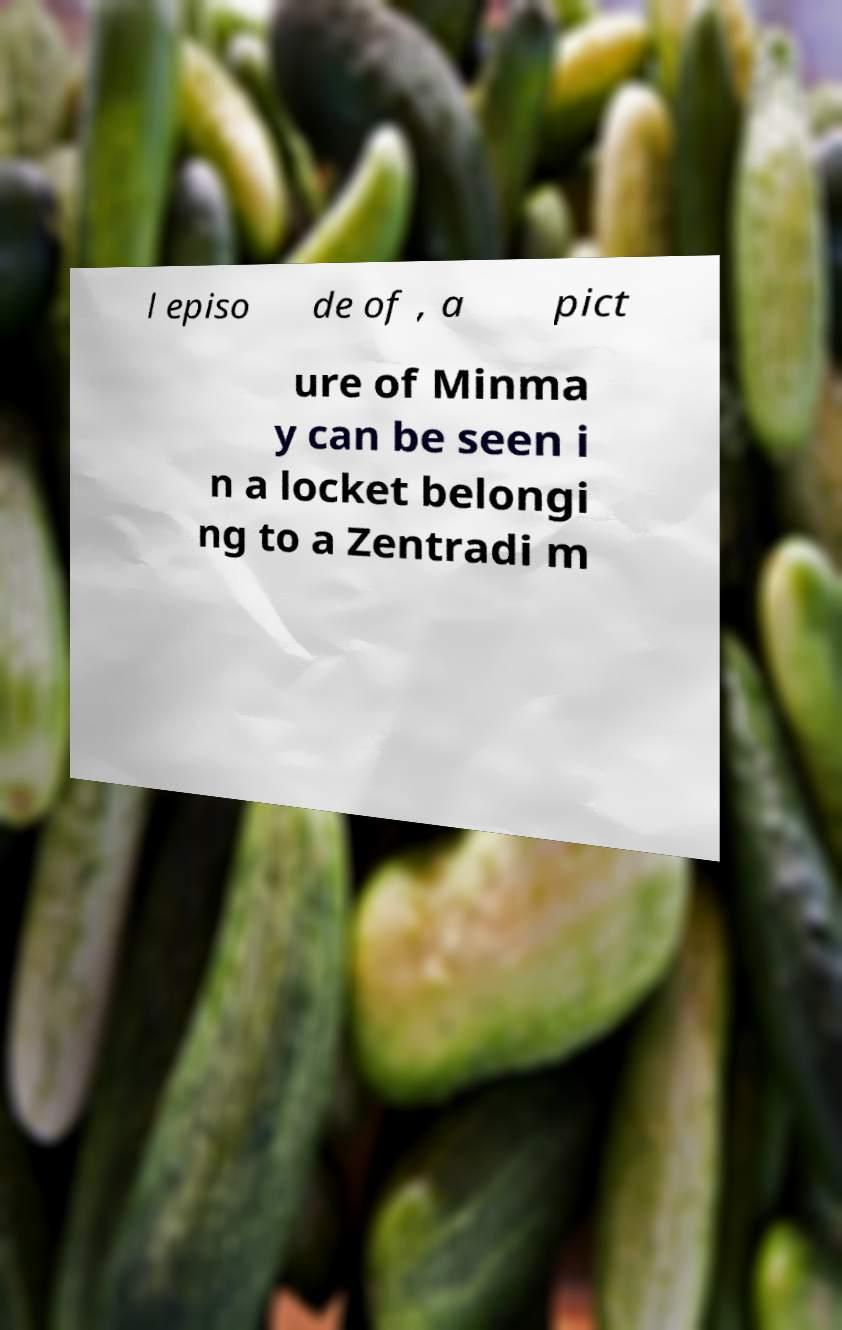I need the written content from this picture converted into text. Can you do that? l episo de of , a pict ure of Minma y can be seen i n a locket belongi ng to a Zentradi m 